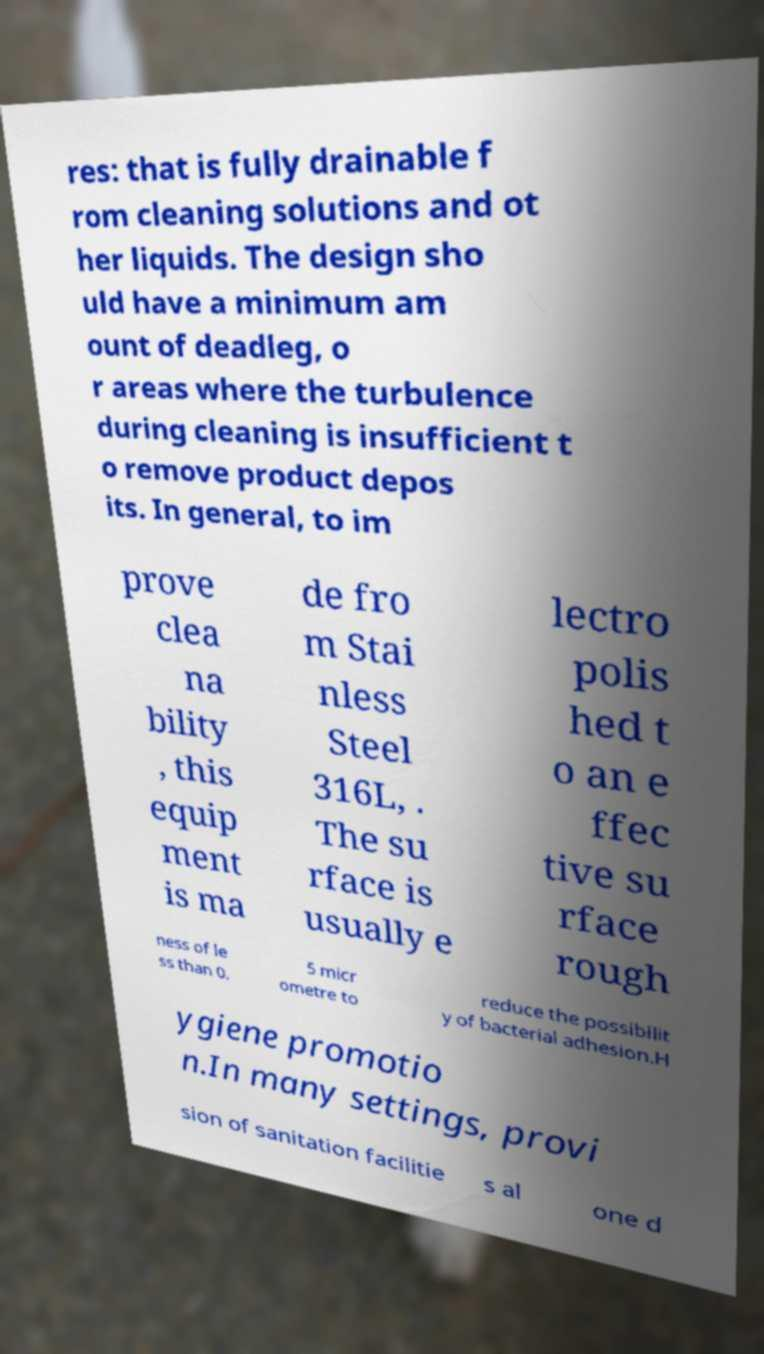I need the written content from this picture converted into text. Can you do that? res: that is fully drainable f rom cleaning solutions and ot her liquids. The design sho uld have a minimum am ount of deadleg, o r areas where the turbulence during cleaning is insufficient t o remove product depos its. In general, to im prove clea na bility , this equip ment is ma de fro m Stai nless Steel 316L, . The su rface is usually e lectro polis hed t o an e ffec tive su rface rough ness of le ss than 0. 5 micr ometre to reduce the possibilit y of bacterial adhesion.H ygiene promotio n.In many settings, provi sion of sanitation facilitie s al one d 